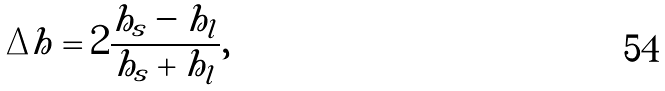<formula> <loc_0><loc_0><loc_500><loc_500>\Delta h = 2 \frac { h _ { s } - h _ { l } } { h _ { s } + h _ { l } } ,</formula> 